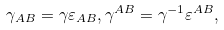<formula> <loc_0><loc_0><loc_500><loc_500>\gamma _ { A B } = \gamma \varepsilon _ { A B } , \gamma ^ { A B } = \gamma ^ { - 1 } \varepsilon ^ { A B } ,</formula> 